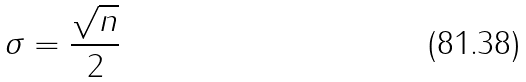<formula> <loc_0><loc_0><loc_500><loc_500>\sigma = \frac { \sqrt { n } } { 2 }</formula> 